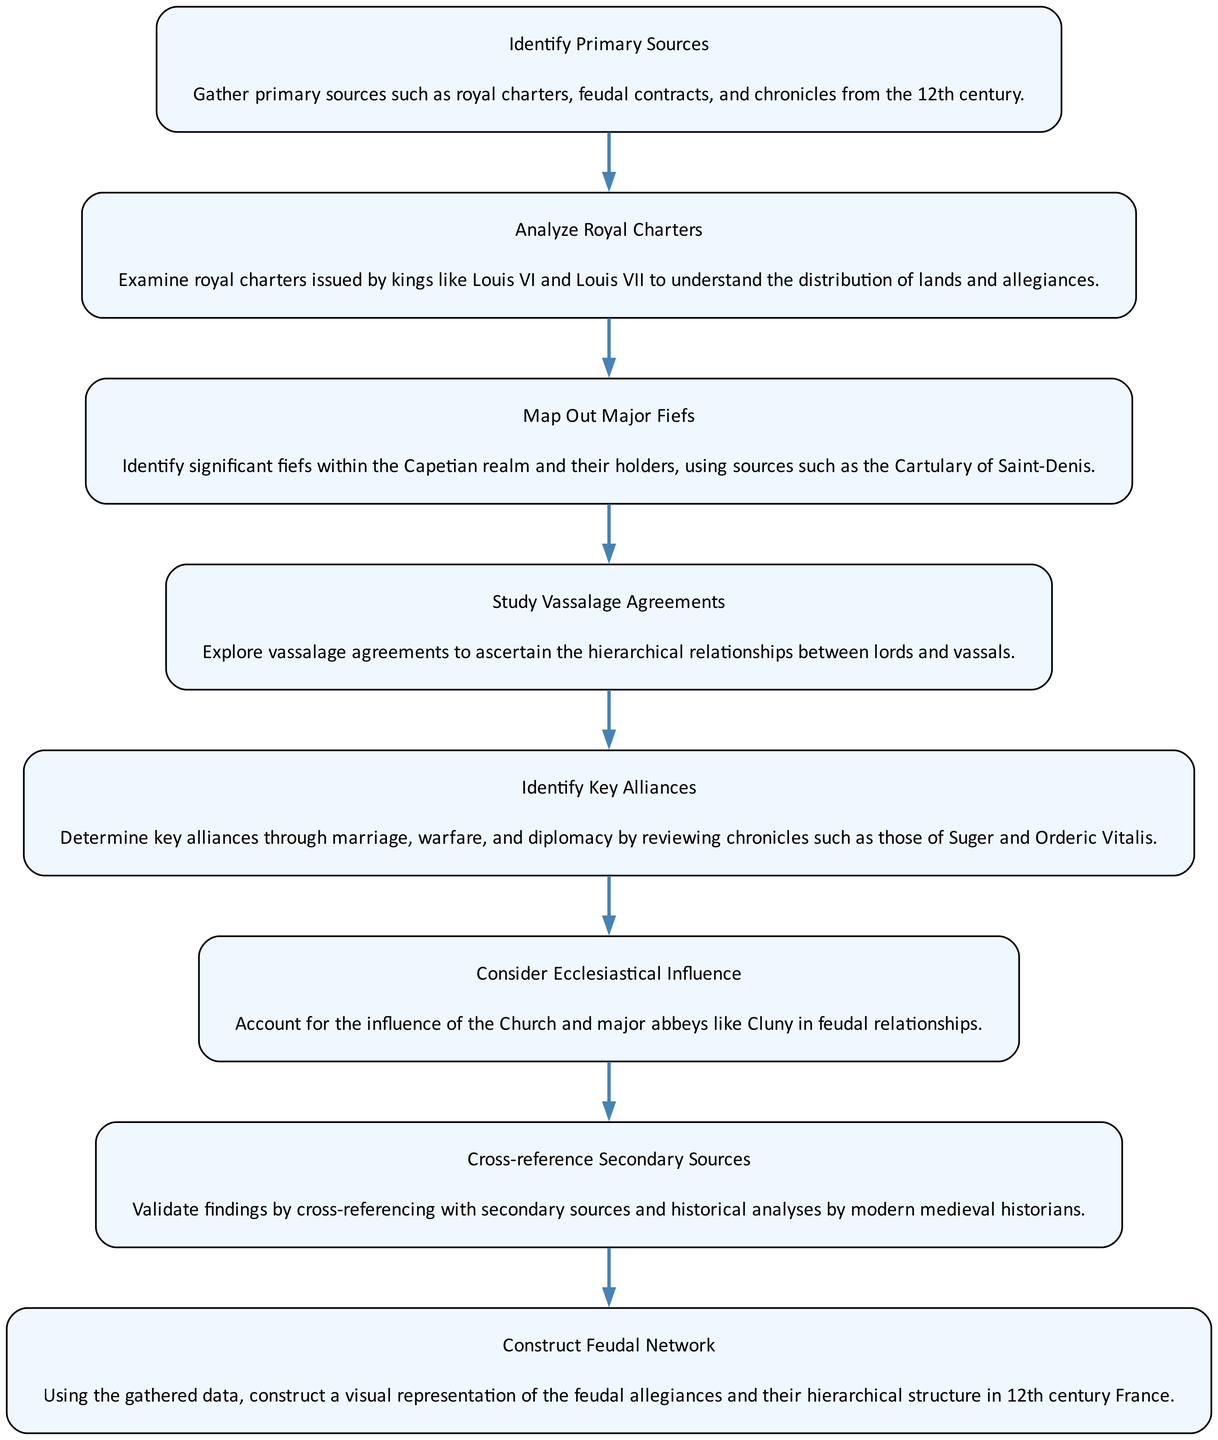What is the first step in reconstructing feudal allegiances? The diagram indicates that the first step is "Identify Primary Sources," which is essential for gathering relevant historical documents.
Answer: Identify Primary Sources How many nodes are there in the diagram? By counting each distinct step or node in the flow chart, we find that there are a total of eight steps.
Answer: 8 Which node follows the analysis of royal charters? According to the flow of the diagram, the node that follows "Analyze Royal Charters" is "Map Out Major Fiefs."
Answer: Map Out Major Fiefs What is the last step in the process? The diagram indicates that the final step is "Construct Feudal Network," which suggests the culmination of all previous efforts to visualize feudal allegiances.
Answer: Construct Feudal Network What role does ecclesiastical influence play in the reconstruction process? The diagram specifies "Consider Ecclesiastical Influence" as an important step, highlighting the Church's impact on feudal relationships.
Answer: Consider Ecclesiastical Influence How are key alliances determined in the diagram? Key alliances are determined by reviewing chronicles which highlight marriage, warfare, and diplomacy. This is specified in the "Identify Key Alliances" step, connecting various historical factors.
Answer: Identify Key Alliances Which elements are vital before constructing the feudal network? Prior to constructing the feudal network, it is essential to analyze royal charters, map out major fiefs, study vassalage agreements, identify key alliances, and consider ecclesiastical influence.
Answer: Analyze Royal Charters, Map Out Major Fiefs, Study Vassalage Agreements, Identify Key Alliances, Consider Ecclesiastical Influence What should be cross-referenced according to the diagram? The diagram specifies that findings should be validated by "Cross-reference Secondary Sources" to ensure accuracy and reliability of the reconstruction.
Answer: Cross-reference Secondary Sources 